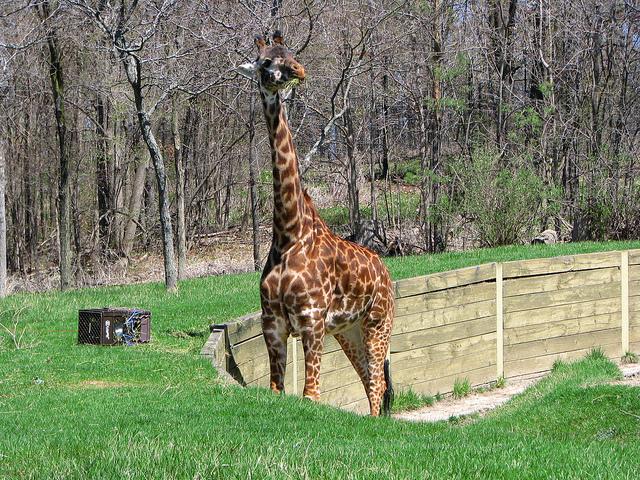What is behind the animal?
Keep it brief. Trees. How many animals are shown?
Write a very short answer. 1. What kind of animal is this?
Answer briefly. Giraffe. 